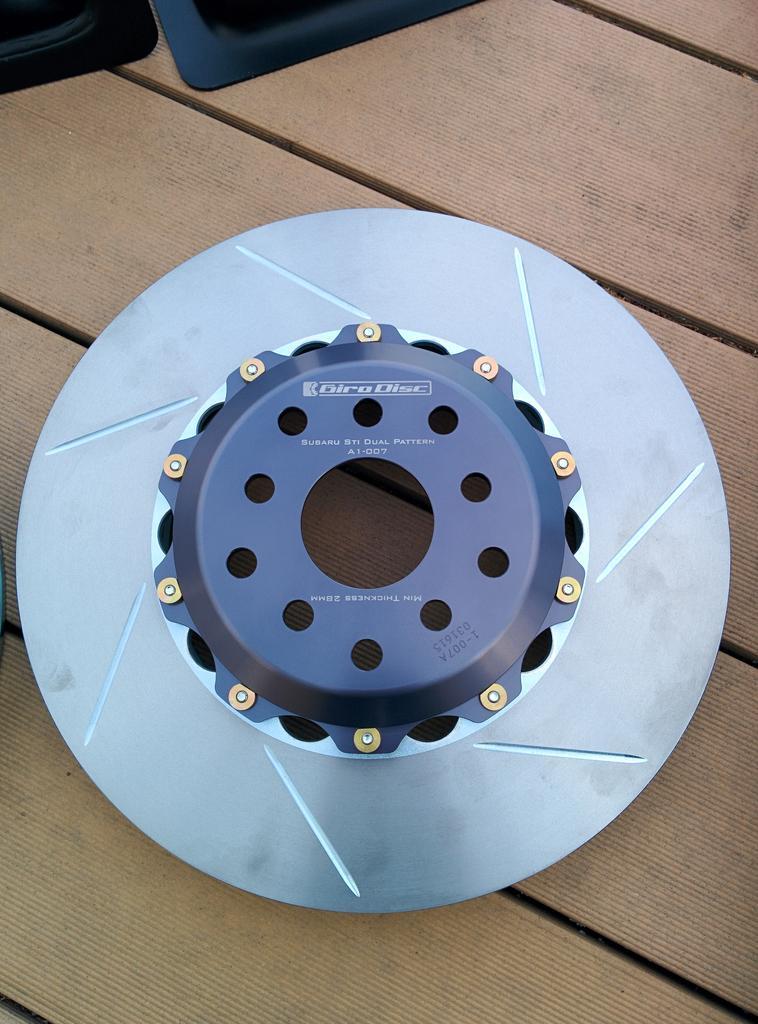Describe this image in one or two sentences. In this picture there is a metal disc brake, placed on the wooden table top. 